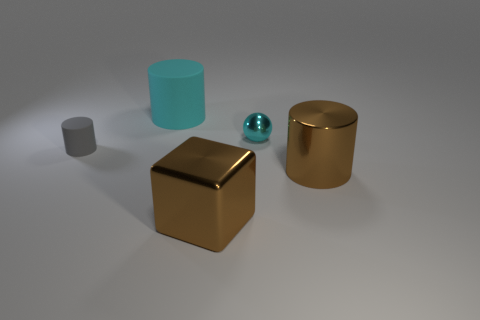What number of spheres are cyan objects or large gray metal objects?
Your response must be concise. 1. What is the size of the brown cube that is the same material as the tiny cyan thing?
Give a very brief answer. Large. Is the size of the matte object that is in front of the large cyan matte thing the same as the brown metal thing behind the cube?
Your answer should be compact. No. What number of things are cyan rubber things or tiny purple things?
Provide a succinct answer. 1. What is the shape of the cyan matte object?
Your answer should be compact. Cylinder. What is the size of the brown object that is the same shape as the small gray object?
Offer a very short reply. Large. Is there any other thing that is made of the same material as the large brown cylinder?
Your response must be concise. Yes. What is the size of the metal thing behind the brown thing that is to the right of the big metal block?
Your response must be concise. Small. Is the number of big matte things that are behind the big cyan object the same as the number of blue matte cylinders?
Provide a succinct answer. Yes. What number of other objects are the same color as the small rubber thing?
Offer a very short reply. 0. 